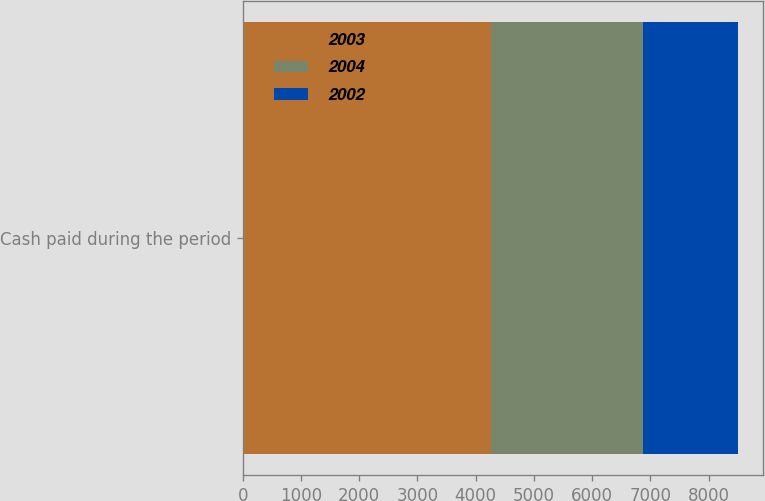<chart> <loc_0><loc_0><loc_500><loc_500><stacked_bar_chart><ecel><fcel>Cash paid during the period<nl><fcel>2003<fcel>4257<nl><fcel>2004<fcel>2609<nl><fcel>2002<fcel>1640<nl></chart> 